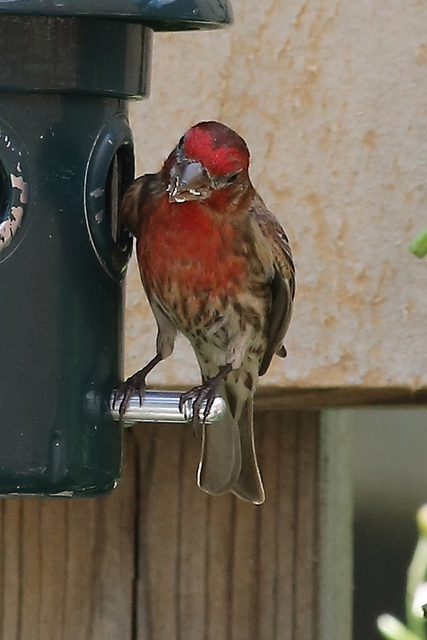Describe the objects in this image and their specific colors. I can see a bird in gray, maroon, and black tones in this image. 